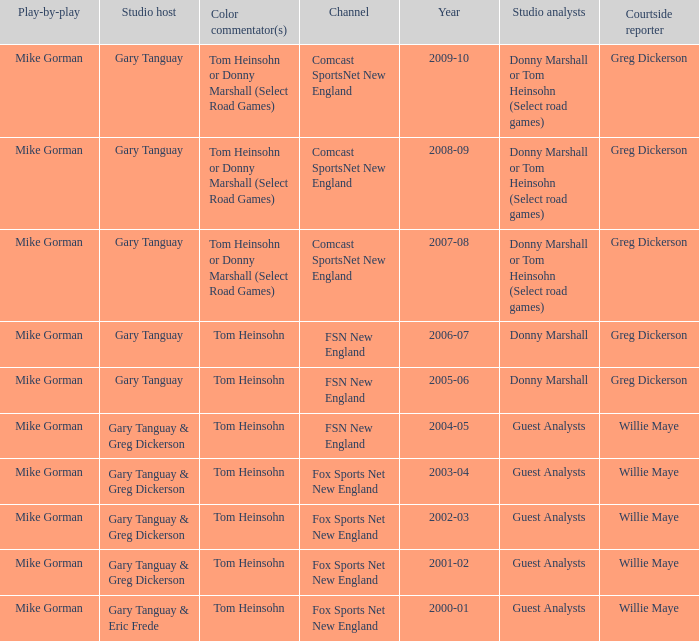WHich Studio analysts has a Studio host of gary tanguay in 2009-10? Donny Marshall or Tom Heinsohn (Select road games). 